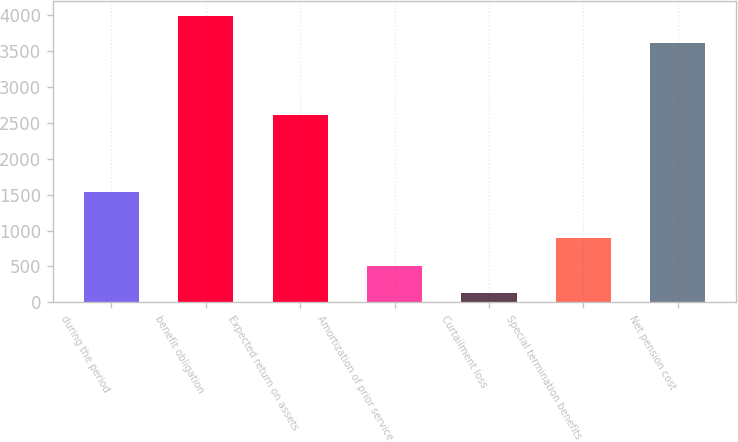<chart> <loc_0><loc_0><loc_500><loc_500><bar_chart><fcel>during the period<fcel>benefit obligation<fcel>Expected return on assets<fcel>Amortization of prior service<fcel>Curtailment loss<fcel>Special termination benefits<fcel>Net pension cost<nl><fcel>1539<fcel>3995.9<fcel>2616<fcel>511.9<fcel>129<fcel>894.8<fcel>3613<nl></chart> 